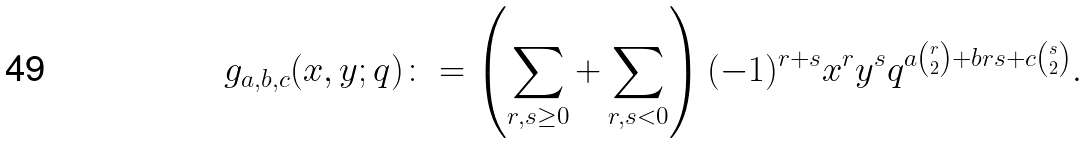<formula> <loc_0><loc_0><loc_500><loc_500>g _ { a , b , c } ( x , y ; q ) \colon = \left ( \sum _ { r , s \geq 0 } + \sum _ { r , s < 0 } \right ) ( - 1 ) ^ { r + s } x ^ { r } y ^ { s } q ^ { a \binom { r } { 2 } + b r s + c \binom { s } { 2 } } .</formula> 